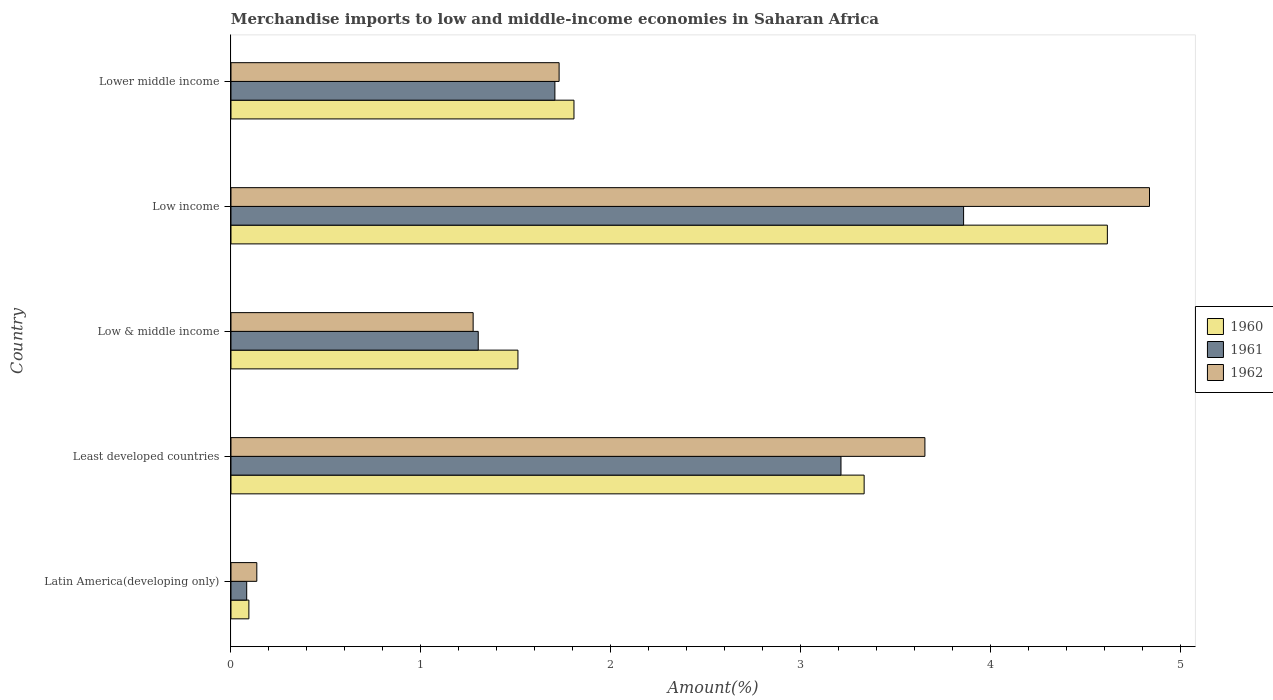How many different coloured bars are there?
Offer a very short reply. 3. Are the number of bars per tick equal to the number of legend labels?
Your answer should be very brief. Yes. Are the number of bars on each tick of the Y-axis equal?
Give a very brief answer. Yes. How many bars are there on the 2nd tick from the bottom?
Offer a very short reply. 3. What is the label of the 1st group of bars from the top?
Provide a short and direct response. Lower middle income. In how many cases, is the number of bars for a given country not equal to the number of legend labels?
Offer a terse response. 0. What is the percentage of amount earned from merchandise imports in 1960 in Least developed countries?
Provide a succinct answer. 3.33. Across all countries, what is the maximum percentage of amount earned from merchandise imports in 1960?
Provide a short and direct response. 4.61. Across all countries, what is the minimum percentage of amount earned from merchandise imports in 1960?
Offer a terse response. 0.09. In which country was the percentage of amount earned from merchandise imports in 1961 maximum?
Give a very brief answer. Low income. In which country was the percentage of amount earned from merchandise imports in 1961 minimum?
Give a very brief answer. Latin America(developing only). What is the total percentage of amount earned from merchandise imports in 1961 in the graph?
Provide a short and direct response. 10.16. What is the difference between the percentage of amount earned from merchandise imports in 1962 in Least developed countries and that in Low income?
Ensure brevity in your answer.  -1.18. What is the difference between the percentage of amount earned from merchandise imports in 1961 in Lower middle income and the percentage of amount earned from merchandise imports in 1960 in Least developed countries?
Offer a terse response. -1.63. What is the average percentage of amount earned from merchandise imports in 1961 per country?
Ensure brevity in your answer.  2.03. What is the difference between the percentage of amount earned from merchandise imports in 1961 and percentage of amount earned from merchandise imports in 1960 in Low income?
Keep it short and to the point. -0.76. What is the ratio of the percentage of amount earned from merchandise imports in 1960 in Latin America(developing only) to that in Least developed countries?
Your answer should be compact. 0.03. Is the percentage of amount earned from merchandise imports in 1961 in Low income less than that in Lower middle income?
Make the answer very short. No. What is the difference between the highest and the second highest percentage of amount earned from merchandise imports in 1960?
Ensure brevity in your answer.  1.28. What is the difference between the highest and the lowest percentage of amount earned from merchandise imports in 1960?
Make the answer very short. 4.52. Is the sum of the percentage of amount earned from merchandise imports in 1962 in Latin America(developing only) and Least developed countries greater than the maximum percentage of amount earned from merchandise imports in 1961 across all countries?
Your answer should be very brief. No. What does the 1st bar from the top in Low & middle income represents?
Your response must be concise. 1962. What does the 2nd bar from the bottom in Least developed countries represents?
Offer a very short reply. 1961. Are all the bars in the graph horizontal?
Make the answer very short. Yes. Does the graph contain any zero values?
Provide a succinct answer. No. Does the graph contain grids?
Your answer should be very brief. No. How are the legend labels stacked?
Your response must be concise. Vertical. What is the title of the graph?
Provide a succinct answer. Merchandise imports to low and middle-income economies in Saharan Africa. Does "1966" appear as one of the legend labels in the graph?
Ensure brevity in your answer.  No. What is the label or title of the X-axis?
Your answer should be very brief. Amount(%). What is the Amount(%) of 1960 in Latin America(developing only)?
Offer a terse response. 0.09. What is the Amount(%) in 1961 in Latin America(developing only)?
Keep it short and to the point. 0.08. What is the Amount(%) in 1962 in Latin America(developing only)?
Offer a terse response. 0.14. What is the Amount(%) of 1960 in Least developed countries?
Make the answer very short. 3.33. What is the Amount(%) of 1961 in Least developed countries?
Make the answer very short. 3.21. What is the Amount(%) in 1962 in Least developed countries?
Give a very brief answer. 3.65. What is the Amount(%) in 1960 in Low & middle income?
Provide a succinct answer. 1.51. What is the Amount(%) in 1961 in Low & middle income?
Offer a terse response. 1.3. What is the Amount(%) in 1962 in Low & middle income?
Keep it short and to the point. 1.27. What is the Amount(%) in 1960 in Low income?
Keep it short and to the point. 4.61. What is the Amount(%) in 1961 in Low income?
Offer a very short reply. 3.86. What is the Amount(%) in 1962 in Low income?
Provide a succinct answer. 4.84. What is the Amount(%) in 1960 in Lower middle income?
Your answer should be very brief. 1.81. What is the Amount(%) in 1961 in Lower middle income?
Make the answer very short. 1.71. What is the Amount(%) in 1962 in Lower middle income?
Ensure brevity in your answer.  1.73. Across all countries, what is the maximum Amount(%) in 1960?
Give a very brief answer. 4.61. Across all countries, what is the maximum Amount(%) of 1961?
Provide a succinct answer. 3.86. Across all countries, what is the maximum Amount(%) of 1962?
Make the answer very short. 4.84. Across all countries, what is the minimum Amount(%) in 1960?
Your answer should be compact. 0.09. Across all countries, what is the minimum Amount(%) of 1961?
Your answer should be compact. 0.08. Across all countries, what is the minimum Amount(%) in 1962?
Offer a very short reply. 0.14. What is the total Amount(%) in 1960 in the graph?
Your answer should be very brief. 11.36. What is the total Amount(%) in 1961 in the graph?
Offer a very short reply. 10.16. What is the total Amount(%) of 1962 in the graph?
Your answer should be very brief. 11.63. What is the difference between the Amount(%) in 1960 in Latin America(developing only) and that in Least developed countries?
Make the answer very short. -3.24. What is the difference between the Amount(%) in 1961 in Latin America(developing only) and that in Least developed countries?
Make the answer very short. -3.13. What is the difference between the Amount(%) in 1962 in Latin America(developing only) and that in Least developed countries?
Provide a succinct answer. -3.52. What is the difference between the Amount(%) of 1960 in Latin America(developing only) and that in Low & middle income?
Offer a very short reply. -1.42. What is the difference between the Amount(%) of 1961 in Latin America(developing only) and that in Low & middle income?
Keep it short and to the point. -1.22. What is the difference between the Amount(%) of 1962 in Latin America(developing only) and that in Low & middle income?
Ensure brevity in your answer.  -1.14. What is the difference between the Amount(%) in 1960 in Latin America(developing only) and that in Low income?
Offer a very short reply. -4.52. What is the difference between the Amount(%) in 1961 in Latin America(developing only) and that in Low income?
Give a very brief answer. -3.77. What is the difference between the Amount(%) of 1962 in Latin America(developing only) and that in Low income?
Your answer should be very brief. -4.7. What is the difference between the Amount(%) in 1960 in Latin America(developing only) and that in Lower middle income?
Keep it short and to the point. -1.71. What is the difference between the Amount(%) of 1961 in Latin America(developing only) and that in Lower middle income?
Your answer should be very brief. -1.62. What is the difference between the Amount(%) in 1962 in Latin America(developing only) and that in Lower middle income?
Ensure brevity in your answer.  -1.59. What is the difference between the Amount(%) of 1960 in Least developed countries and that in Low & middle income?
Offer a terse response. 1.82. What is the difference between the Amount(%) in 1961 in Least developed countries and that in Low & middle income?
Give a very brief answer. 1.91. What is the difference between the Amount(%) of 1962 in Least developed countries and that in Low & middle income?
Your answer should be compact. 2.38. What is the difference between the Amount(%) of 1960 in Least developed countries and that in Low income?
Provide a succinct answer. -1.28. What is the difference between the Amount(%) in 1961 in Least developed countries and that in Low income?
Ensure brevity in your answer.  -0.65. What is the difference between the Amount(%) in 1962 in Least developed countries and that in Low income?
Provide a succinct answer. -1.18. What is the difference between the Amount(%) in 1960 in Least developed countries and that in Lower middle income?
Your answer should be very brief. 1.53. What is the difference between the Amount(%) in 1961 in Least developed countries and that in Lower middle income?
Make the answer very short. 1.51. What is the difference between the Amount(%) in 1962 in Least developed countries and that in Lower middle income?
Keep it short and to the point. 1.93. What is the difference between the Amount(%) in 1960 in Low & middle income and that in Low income?
Offer a very short reply. -3.1. What is the difference between the Amount(%) in 1961 in Low & middle income and that in Low income?
Give a very brief answer. -2.56. What is the difference between the Amount(%) in 1962 in Low & middle income and that in Low income?
Make the answer very short. -3.56. What is the difference between the Amount(%) of 1960 in Low & middle income and that in Lower middle income?
Keep it short and to the point. -0.29. What is the difference between the Amount(%) of 1961 in Low & middle income and that in Lower middle income?
Give a very brief answer. -0.4. What is the difference between the Amount(%) of 1962 in Low & middle income and that in Lower middle income?
Ensure brevity in your answer.  -0.45. What is the difference between the Amount(%) in 1960 in Low income and that in Lower middle income?
Ensure brevity in your answer.  2.81. What is the difference between the Amount(%) in 1961 in Low income and that in Lower middle income?
Provide a short and direct response. 2.15. What is the difference between the Amount(%) of 1962 in Low income and that in Lower middle income?
Keep it short and to the point. 3.11. What is the difference between the Amount(%) of 1960 in Latin America(developing only) and the Amount(%) of 1961 in Least developed countries?
Your answer should be very brief. -3.12. What is the difference between the Amount(%) in 1960 in Latin America(developing only) and the Amount(%) in 1962 in Least developed countries?
Ensure brevity in your answer.  -3.56. What is the difference between the Amount(%) in 1961 in Latin America(developing only) and the Amount(%) in 1962 in Least developed countries?
Your response must be concise. -3.57. What is the difference between the Amount(%) in 1960 in Latin America(developing only) and the Amount(%) in 1961 in Low & middle income?
Offer a very short reply. -1.21. What is the difference between the Amount(%) in 1960 in Latin America(developing only) and the Amount(%) in 1962 in Low & middle income?
Your answer should be very brief. -1.18. What is the difference between the Amount(%) of 1961 in Latin America(developing only) and the Amount(%) of 1962 in Low & middle income?
Offer a terse response. -1.19. What is the difference between the Amount(%) in 1960 in Latin America(developing only) and the Amount(%) in 1961 in Low income?
Your answer should be compact. -3.76. What is the difference between the Amount(%) of 1960 in Latin America(developing only) and the Amount(%) of 1962 in Low income?
Make the answer very short. -4.74. What is the difference between the Amount(%) in 1961 in Latin America(developing only) and the Amount(%) in 1962 in Low income?
Make the answer very short. -4.75. What is the difference between the Amount(%) in 1960 in Latin America(developing only) and the Amount(%) in 1961 in Lower middle income?
Provide a succinct answer. -1.61. What is the difference between the Amount(%) in 1960 in Latin America(developing only) and the Amount(%) in 1962 in Lower middle income?
Offer a very short reply. -1.63. What is the difference between the Amount(%) of 1961 in Latin America(developing only) and the Amount(%) of 1962 in Lower middle income?
Your response must be concise. -1.64. What is the difference between the Amount(%) in 1960 in Least developed countries and the Amount(%) in 1961 in Low & middle income?
Make the answer very short. 2.03. What is the difference between the Amount(%) in 1960 in Least developed countries and the Amount(%) in 1962 in Low & middle income?
Keep it short and to the point. 2.06. What is the difference between the Amount(%) in 1961 in Least developed countries and the Amount(%) in 1962 in Low & middle income?
Offer a very short reply. 1.94. What is the difference between the Amount(%) in 1960 in Least developed countries and the Amount(%) in 1961 in Low income?
Your answer should be very brief. -0.52. What is the difference between the Amount(%) of 1960 in Least developed countries and the Amount(%) of 1962 in Low income?
Provide a succinct answer. -1.5. What is the difference between the Amount(%) in 1961 in Least developed countries and the Amount(%) in 1962 in Low income?
Make the answer very short. -1.62. What is the difference between the Amount(%) in 1960 in Least developed countries and the Amount(%) in 1961 in Lower middle income?
Offer a terse response. 1.63. What is the difference between the Amount(%) in 1960 in Least developed countries and the Amount(%) in 1962 in Lower middle income?
Offer a very short reply. 1.61. What is the difference between the Amount(%) of 1961 in Least developed countries and the Amount(%) of 1962 in Lower middle income?
Your answer should be compact. 1.48. What is the difference between the Amount(%) in 1960 in Low & middle income and the Amount(%) in 1961 in Low income?
Offer a terse response. -2.35. What is the difference between the Amount(%) in 1960 in Low & middle income and the Amount(%) in 1962 in Low income?
Offer a terse response. -3.32. What is the difference between the Amount(%) of 1961 in Low & middle income and the Amount(%) of 1962 in Low income?
Offer a terse response. -3.53. What is the difference between the Amount(%) in 1960 in Low & middle income and the Amount(%) in 1961 in Lower middle income?
Make the answer very short. -0.19. What is the difference between the Amount(%) of 1960 in Low & middle income and the Amount(%) of 1962 in Lower middle income?
Offer a terse response. -0.22. What is the difference between the Amount(%) in 1961 in Low & middle income and the Amount(%) in 1962 in Lower middle income?
Your answer should be compact. -0.43. What is the difference between the Amount(%) of 1960 in Low income and the Amount(%) of 1961 in Lower middle income?
Offer a terse response. 2.91. What is the difference between the Amount(%) of 1960 in Low income and the Amount(%) of 1962 in Lower middle income?
Make the answer very short. 2.89. What is the difference between the Amount(%) of 1961 in Low income and the Amount(%) of 1962 in Lower middle income?
Provide a succinct answer. 2.13. What is the average Amount(%) of 1960 per country?
Ensure brevity in your answer.  2.27. What is the average Amount(%) of 1961 per country?
Keep it short and to the point. 2.03. What is the average Amount(%) in 1962 per country?
Give a very brief answer. 2.33. What is the difference between the Amount(%) of 1960 and Amount(%) of 1961 in Latin America(developing only)?
Give a very brief answer. 0.01. What is the difference between the Amount(%) in 1960 and Amount(%) in 1962 in Latin America(developing only)?
Your answer should be very brief. -0.04. What is the difference between the Amount(%) of 1961 and Amount(%) of 1962 in Latin America(developing only)?
Keep it short and to the point. -0.05. What is the difference between the Amount(%) of 1960 and Amount(%) of 1961 in Least developed countries?
Make the answer very short. 0.12. What is the difference between the Amount(%) in 1960 and Amount(%) in 1962 in Least developed countries?
Offer a very short reply. -0.32. What is the difference between the Amount(%) of 1961 and Amount(%) of 1962 in Least developed countries?
Give a very brief answer. -0.44. What is the difference between the Amount(%) in 1960 and Amount(%) in 1961 in Low & middle income?
Make the answer very short. 0.21. What is the difference between the Amount(%) in 1960 and Amount(%) in 1962 in Low & middle income?
Your response must be concise. 0.24. What is the difference between the Amount(%) of 1961 and Amount(%) of 1962 in Low & middle income?
Ensure brevity in your answer.  0.03. What is the difference between the Amount(%) of 1960 and Amount(%) of 1961 in Low income?
Make the answer very short. 0.76. What is the difference between the Amount(%) of 1960 and Amount(%) of 1962 in Low income?
Your answer should be very brief. -0.22. What is the difference between the Amount(%) in 1961 and Amount(%) in 1962 in Low income?
Make the answer very short. -0.98. What is the difference between the Amount(%) of 1960 and Amount(%) of 1961 in Lower middle income?
Provide a short and direct response. 0.1. What is the difference between the Amount(%) of 1960 and Amount(%) of 1962 in Lower middle income?
Offer a very short reply. 0.08. What is the difference between the Amount(%) of 1961 and Amount(%) of 1962 in Lower middle income?
Your answer should be very brief. -0.02. What is the ratio of the Amount(%) of 1960 in Latin America(developing only) to that in Least developed countries?
Make the answer very short. 0.03. What is the ratio of the Amount(%) in 1961 in Latin America(developing only) to that in Least developed countries?
Offer a terse response. 0.03. What is the ratio of the Amount(%) in 1962 in Latin America(developing only) to that in Least developed countries?
Ensure brevity in your answer.  0.04. What is the ratio of the Amount(%) of 1960 in Latin America(developing only) to that in Low & middle income?
Offer a terse response. 0.06. What is the ratio of the Amount(%) in 1961 in Latin America(developing only) to that in Low & middle income?
Offer a terse response. 0.06. What is the ratio of the Amount(%) in 1962 in Latin America(developing only) to that in Low & middle income?
Provide a short and direct response. 0.11. What is the ratio of the Amount(%) in 1960 in Latin America(developing only) to that in Low income?
Offer a very short reply. 0.02. What is the ratio of the Amount(%) in 1961 in Latin America(developing only) to that in Low income?
Your response must be concise. 0.02. What is the ratio of the Amount(%) in 1962 in Latin America(developing only) to that in Low income?
Give a very brief answer. 0.03. What is the ratio of the Amount(%) in 1960 in Latin America(developing only) to that in Lower middle income?
Provide a succinct answer. 0.05. What is the ratio of the Amount(%) of 1961 in Latin America(developing only) to that in Lower middle income?
Provide a short and direct response. 0.05. What is the ratio of the Amount(%) in 1962 in Latin America(developing only) to that in Lower middle income?
Your answer should be compact. 0.08. What is the ratio of the Amount(%) of 1960 in Least developed countries to that in Low & middle income?
Provide a short and direct response. 2.21. What is the ratio of the Amount(%) in 1961 in Least developed countries to that in Low & middle income?
Offer a very short reply. 2.47. What is the ratio of the Amount(%) of 1962 in Least developed countries to that in Low & middle income?
Offer a terse response. 2.87. What is the ratio of the Amount(%) of 1960 in Least developed countries to that in Low income?
Offer a very short reply. 0.72. What is the ratio of the Amount(%) in 1961 in Least developed countries to that in Low income?
Provide a succinct answer. 0.83. What is the ratio of the Amount(%) of 1962 in Least developed countries to that in Low income?
Make the answer very short. 0.76. What is the ratio of the Amount(%) in 1960 in Least developed countries to that in Lower middle income?
Your answer should be very brief. 1.85. What is the ratio of the Amount(%) of 1961 in Least developed countries to that in Lower middle income?
Your answer should be compact. 1.88. What is the ratio of the Amount(%) in 1962 in Least developed countries to that in Lower middle income?
Your answer should be very brief. 2.11. What is the ratio of the Amount(%) of 1960 in Low & middle income to that in Low income?
Offer a very short reply. 0.33. What is the ratio of the Amount(%) in 1961 in Low & middle income to that in Low income?
Your answer should be very brief. 0.34. What is the ratio of the Amount(%) of 1962 in Low & middle income to that in Low income?
Provide a short and direct response. 0.26. What is the ratio of the Amount(%) of 1960 in Low & middle income to that in Lower middle income?
Provide a succinct answer. 0.84. What is the ratio of the Amount(%) of 1961 in Low & middle income to that in Lower middle income?
Ensure brevity in your answer.  0.76. What is the ratio of the Amount(%) of 1962 in Low & middle income to that in Lower middle income?
Give a very brief answer. 0.74. What is the ratio of the Amount(%) of 1960 in Low income to that in Lower middle income?
Keep it short and to the point. 2.56. What is the ratio of the Amount(%) of 1961 in Low income to that in Lower middle income?
Keep it short and to the point. 2.26. What is the ratio of the Amount(%) of 1962 in Low income to that in Lower middle income?
Keep it short and to the point. 2.8. What is the difference between the highest and the second highest Amount(%) of 1960?
Your response must be concise. 1.28. What is the difference between the highest and the second highest Amount(%) in 1961?
Your answer should be very brief. 0.65. What is the difference between the highest and the second highest Amount(%) in 1962?
Make the answer very short. 1.18. What is the difference between the highest and the lowest Amount(%) in 1960?
Offer a very short reply. 4.52. What is the difference between the highest and the lowest Amount(%) in 1961?
Your response must be concise. 3.77. What is the difference between the highest and the lowest Amount(%) in 1962?
Provide a short and direct response. 4.7. 